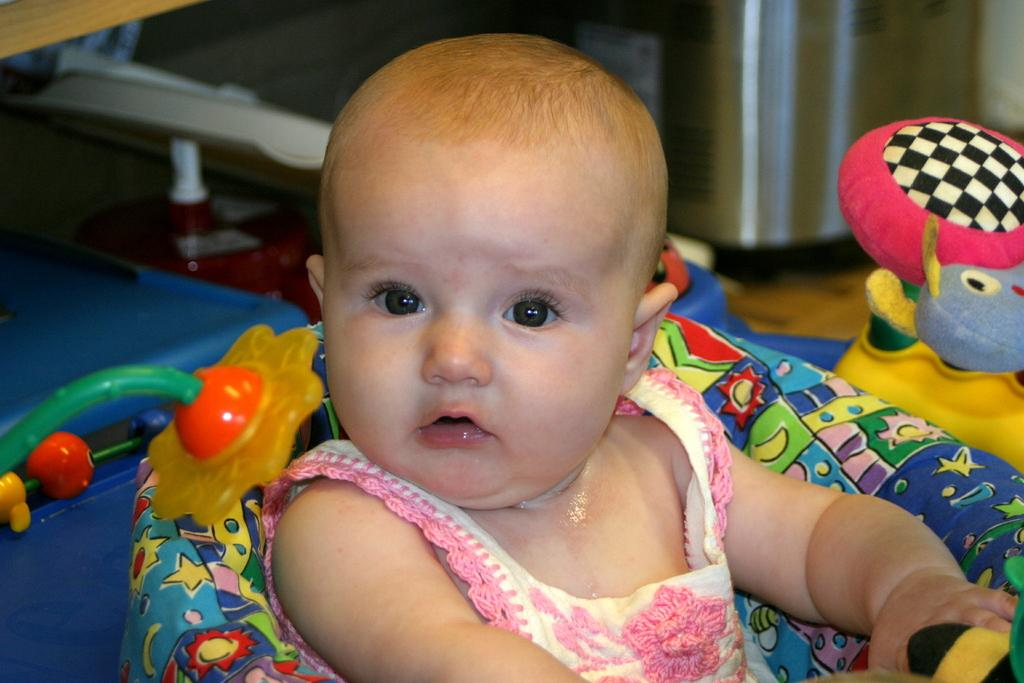What is the main subject in the foreground of the image? There is a baby in a sitter in the foreground of the image. What can be seen in the background of the image? There are other objects in the background of the image. Can you describe any specific object in the background? Yes, there is a toy in the background of the image. What type of ship can be seen sailing in the background of the image? There is no ship visible in the background of the image. How is the honey being used by the baby in the image? There is no honey present in the image; it only features a baby in a sitter and a toy in the background. 